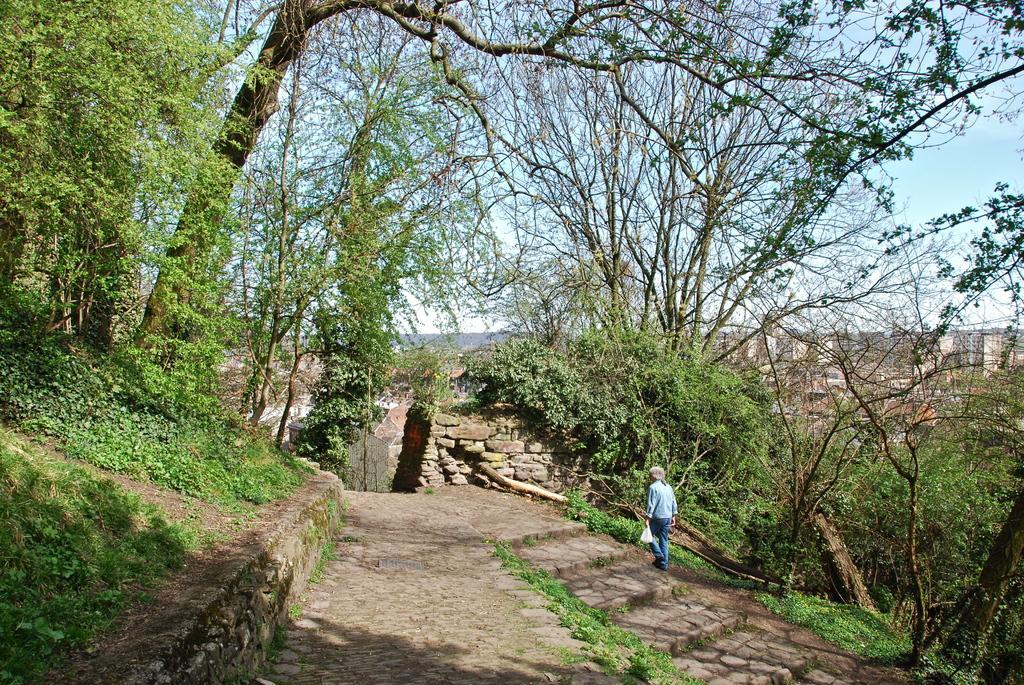Please provide a concise description of this image. There is a road. Near to that there are steps. Also there is a small path. A person holding a cover is walking through that. On the ground there are grasses. There are wall with rocks. On the sides there are many trees. In the background there is sky. 